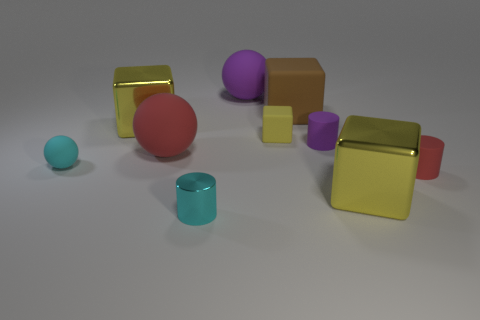What number of small objects are matte cylinders or cyan balls?
Give a very brief answer. 3. There is a cyan rubber object; is it the same size as the yellow cube that is on the left side of the tiny metal object?
Make the answer very short. No. Is there anything else that has the same shape as the tiny yellow thing?
Your answer should be very brief. Yes. How many yellow rubber cubes are there?
Give a very brief answer. 1. What number of red things are matte balls or large balls?
Make the answer very short. 1. Is the large cube in front of the yellow matte object made of the same material as the small ball?
Keep it short and to the point. No. What number of other things are the same material as the small cyan cylinder?
Make the answer very short. 2. What material is the large red object?
Offer a very short reply. Rubber. There is a yellow shiny block right of the big brown rubber object; what size is it?
Your answer should be compact. Large. How many big yellow objects are to the right of the red thing on the left side of the purple matte cylinder?
Your answer should be compact. 1. 